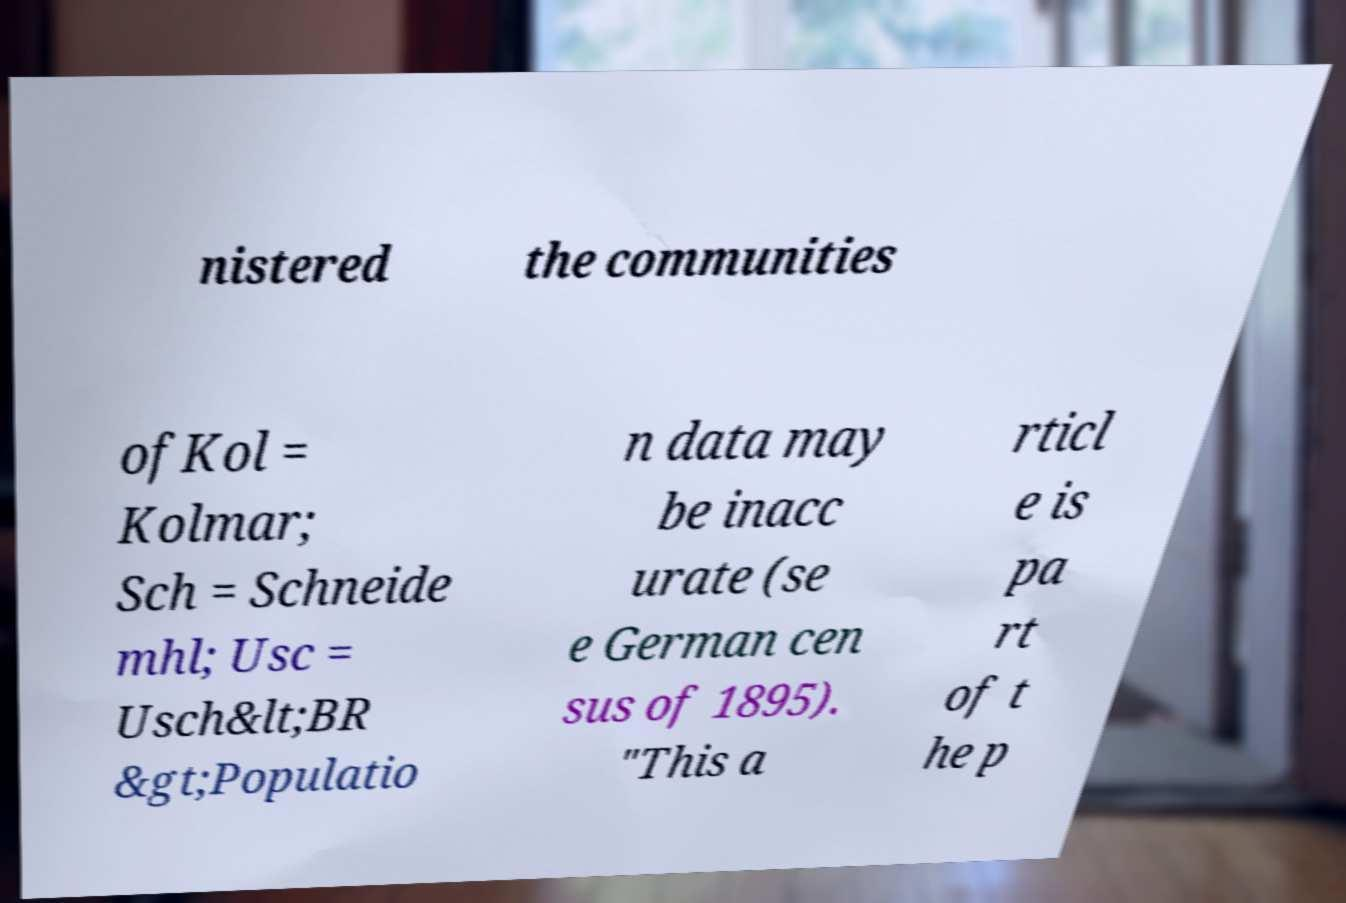Please identify and transcribe the text found in this image. nistered the communities ofKol = Kolmar; Sch = Schneide mhl; Usc = Usch&lt;BR &gt;Populatio n data may be inacc urate (se e German cen sus of 1895). "This a rticl e is pa rt of t he p 